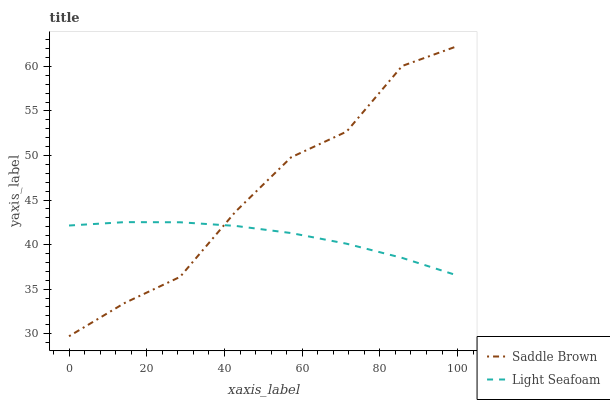Does Light Seafoam have the minimum area under the curve?
Answer yes or no. Yes. Does Saddle Brown have the maximum area under the curve?
Answer yes or no. Yes. Does Saddle Brown have the minimum area under the curve?
Answer yes or no. No. Is Light Seafoam the smoothest?
Answer yes or no. Yes. Is Saddle Brown the roughest?
Answer yes or no. Yes. Is Saddle Brown the smoothest?
Answer yes or no. No. Does Saddle Brown have the lowest value?
Answer yes or no. Yes. Does Saddle Brown have the highest value?
Answer yes or no. Yes. Does Saddle Brown intersect Light Seafoam?
Answer yes or no. Yes. Is Saddle Brown less than Light Seafoam?
Answer yes or no. No. Is Saddle Brown greater than Light Seafoam?
Answer yes or no. No. 